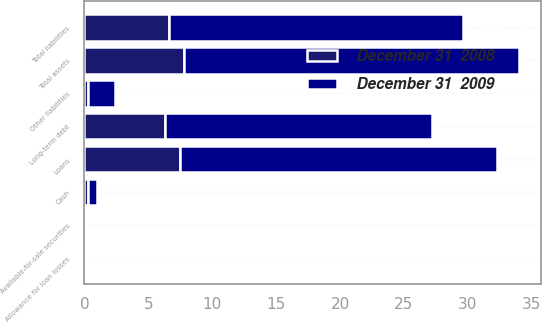<chart> <loc_0><loc_0><loc_500><loc_500><stacked_bar_chart><ecel><fcel>Cash<fcel>Available-for-sale securities<fcel>Loans<fcel>Allowance for loan losses<fcel>Total assets<fcel>Long-term debt<fcel>Other liabilities<fcel>Total liabilities<nl><fcel>December 31  2009<fcel>0.7<fcel>0.1<fcel>24.8<fcel>0.2<fcel>26.2<fcel>20.9<fcel>2.1<fcel>23<nl><fcel>December 31  2008<fcel>0.3<fcel>0.1<fcel>7.5<fcel>0.1<fcel>7.8<fcel>6.3<fcel>0.3<fcel>6.6<nl></chart> 